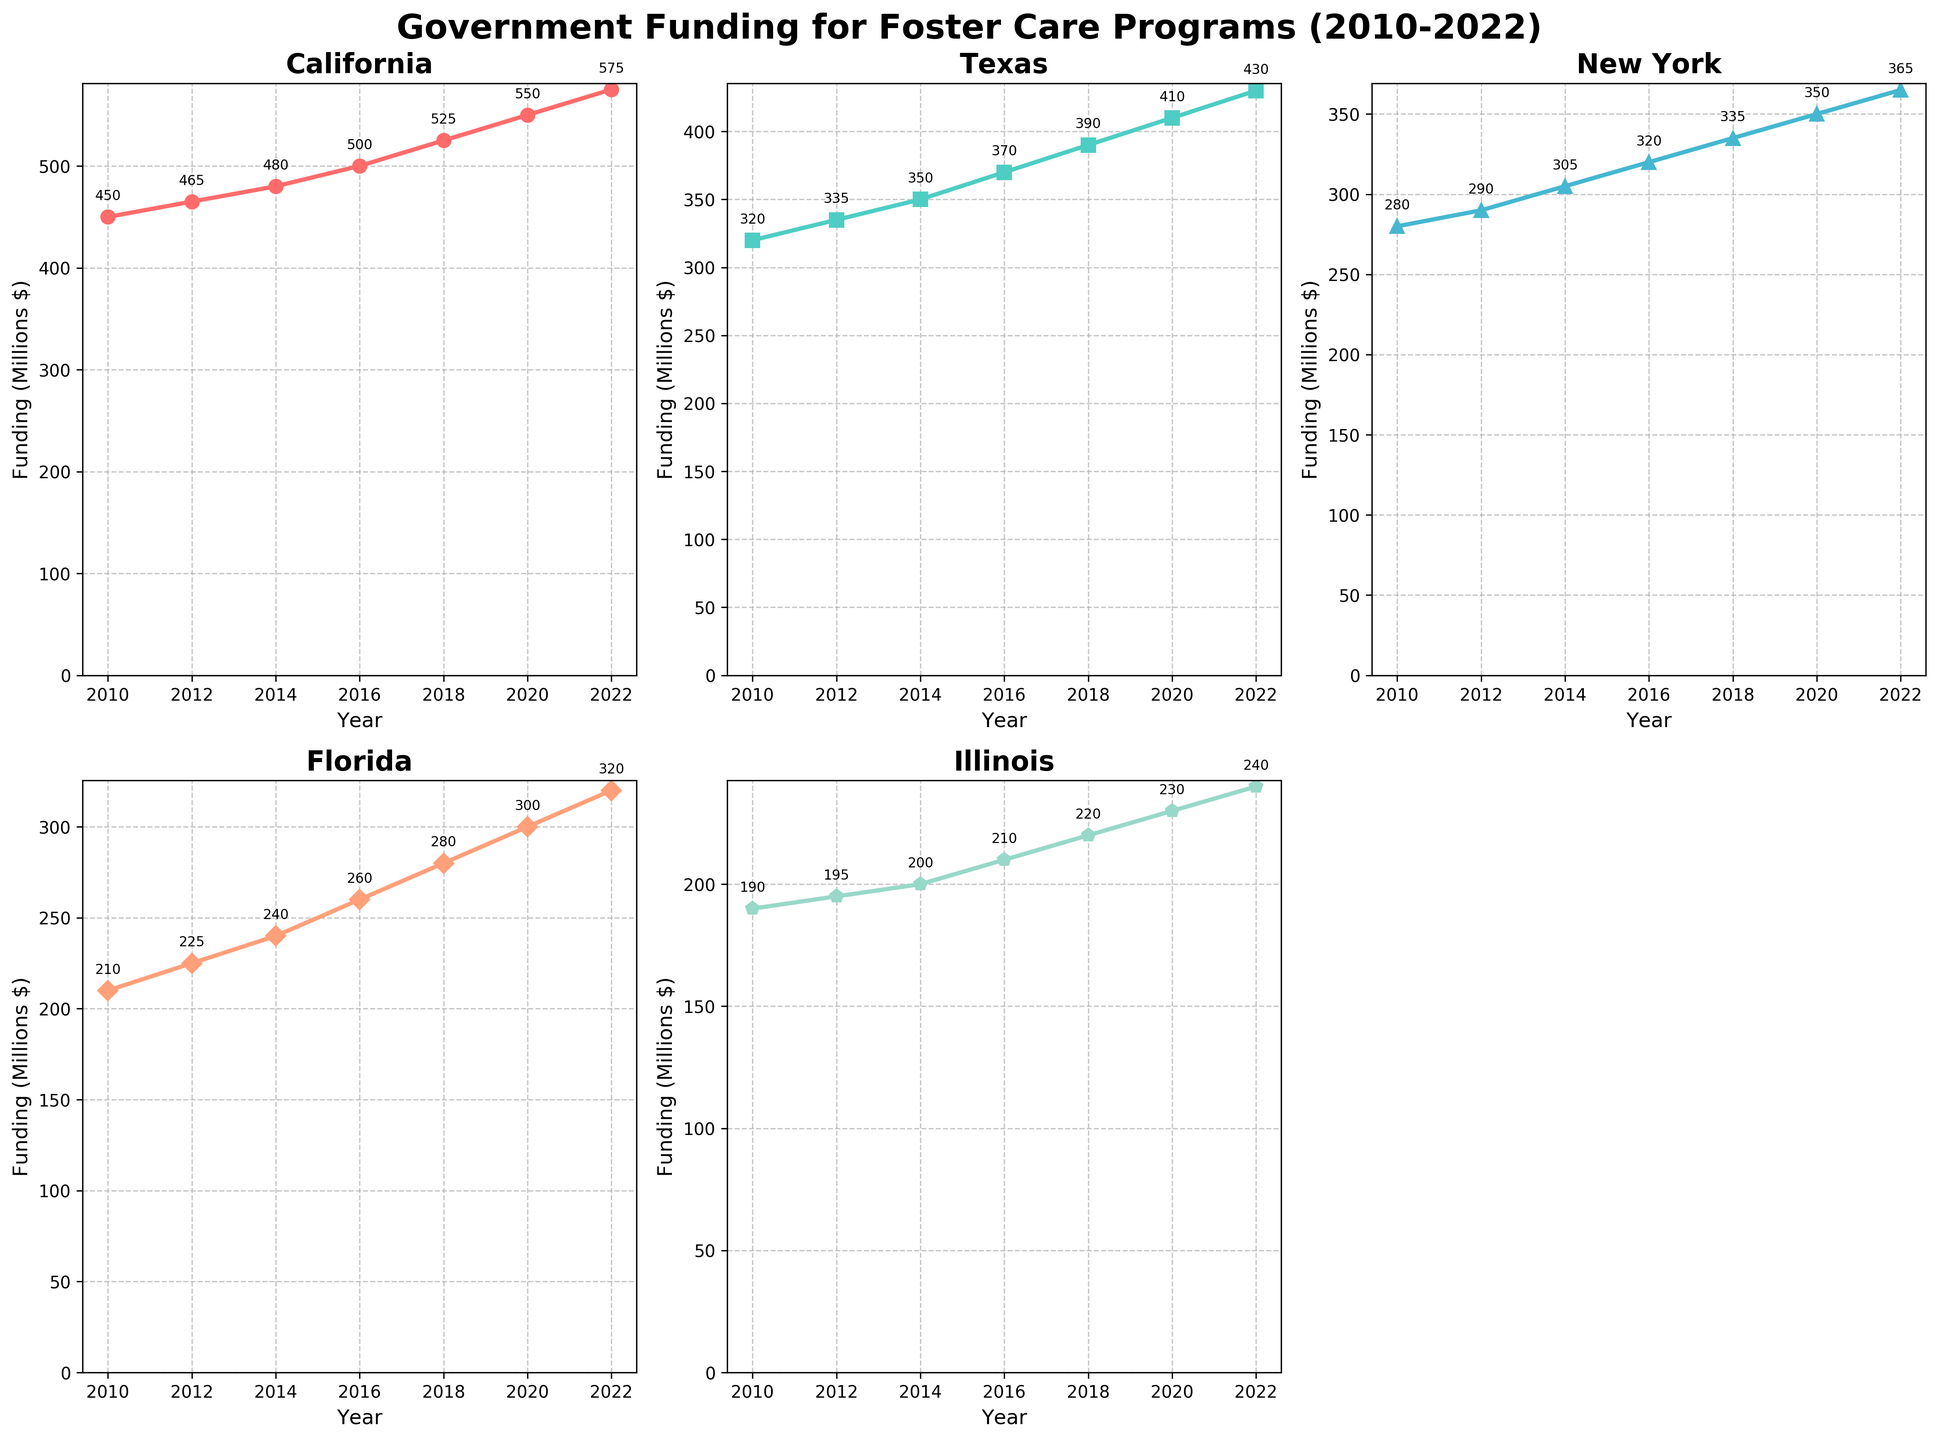What is the title of the figure? The title is prominently displayed at the top of the figure, indicating what the subplot represents.
Answer: "Government Funding for Foster Care Programs (2010-2022)" How many states are included in the subplots? The subplots are titled with the names of each state they represent. By counting these titles, we can see how many states are included.
Answer: 5 states What color represents California in the plot? By looking at the color of the line chart labeled "California", we can determine the color used for this state.
Answer: Red Which state had the highest funding in 2022? By observing the endpoint of each line on the right side of the figure (2022), we can see which state's line is at the highest position.
Answer: California How much funding did Texas receive in 2016? Referring to the plot for Texas, we look at the point on the line corresponding to the year 2016.
Answer: $370 million Which state had the lowest funding in 2010? By observing the starting points of each line on the left side of the figure (2010), we can see which state's line is at the lowest position.
Answer: Illinois Calculate the average annual funding increase for California from 2010 to 2022. First, find the difference in funding between 2010 and 2022 for California ($575 million - $450 million = $125 million). Then, divide this difference by the number of years (2022 - 2010 = 12 years).
Answer: $10.42 million per year Between Texas and Florida, which state had a greater increase in funding from 2010 to 2022? Calculate the increase for each state by subtracting the 2010 value from the 2022 value for both states: Texas ($430 million - $320 million) and Florida ($320 million - $210 million). Compare the two results.
Answer: Texas Compare the funding trend of Illinois to that of New York. Which state had a more consistent increase? By examining the slope of the lines for Illinois and New York, observe which line shows a steadier, more uniform rise over the years.
Answer: New York What is the overall trend in government funding for foster care programs over the years for these states? All lines consistently show an upward trend from 2010 to 2022, indicating an overall increase in funding.
Answer: Increasing 